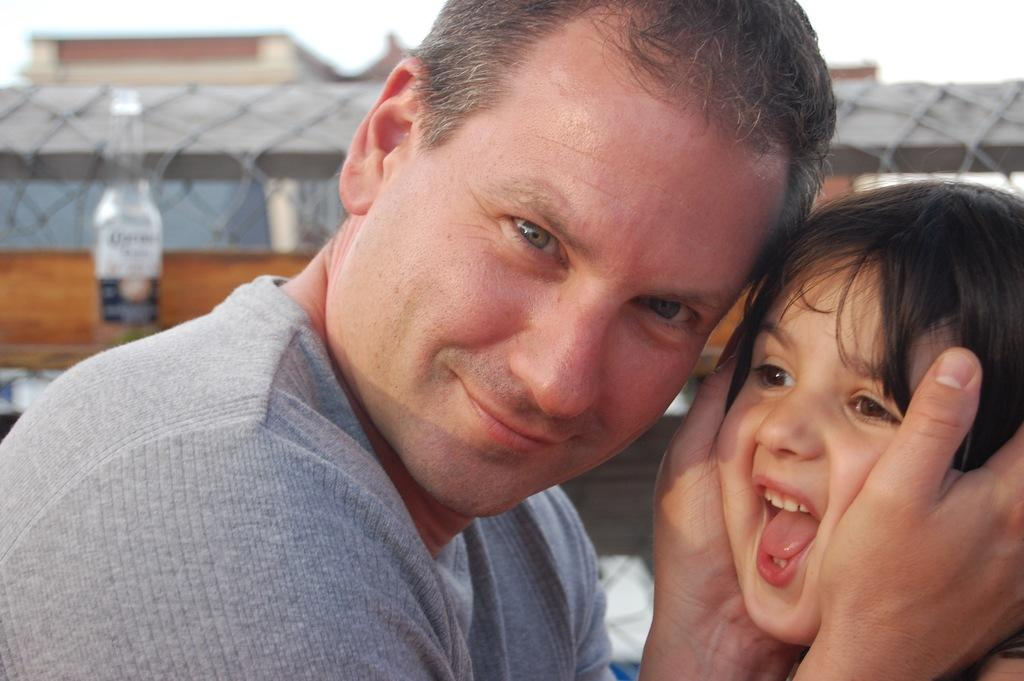What is the man in the image doing with the kid? The man is holding a kid in the image. What objects can be seen in the background of the image? There is a bottle, a wooden stick, a fence, and a building in the background of the image. What part of the natural environment is visible in the image? The sky is visible in the background of the image. How does the earthquake affect the base of the building in the image? There is no earthquake present in the image, so its effects on the building cannot be determined. 